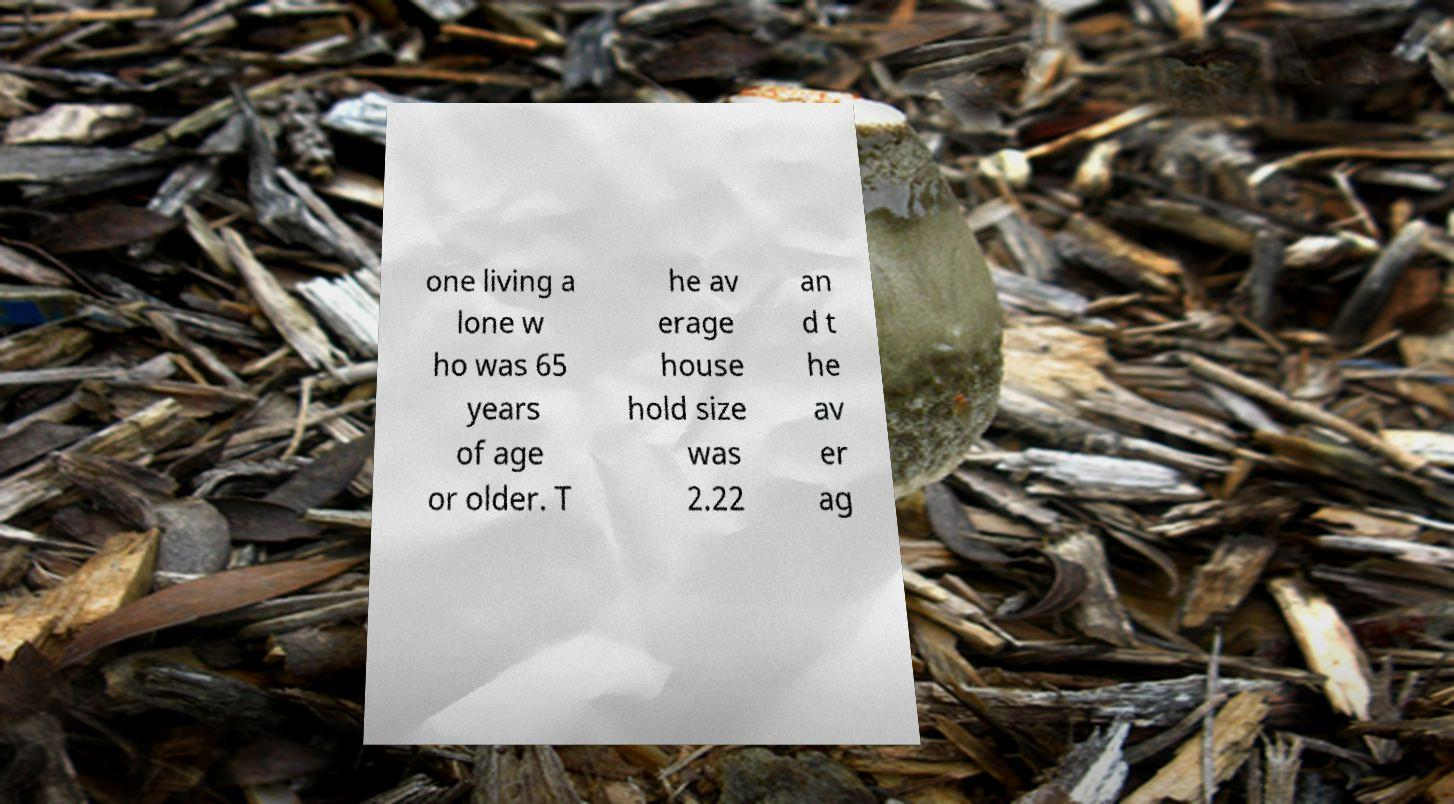I need the written content from this picture converted into text. Can you do that? one living a lone w ho was 65 years of age or older. T he av erage house hold size was 2.22 an d t he av er ag 